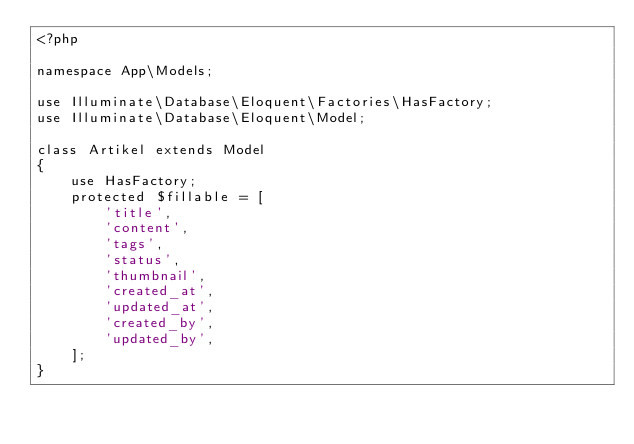Convert code to text. <code><loc_0><loc_0><loc_500><loc_500><_PHP_><?php

namespace App\Models;

use Illuminate\Database\Eloquent\Factories\HasFactory;
use Illuminate\Database\Eloquent\Model;

class Artikel extends Model
{
    use HasFactory;
    protected $fillable = [
        'title',
        'content',
        'tags',
        'status',
        'thumbnail',
        'created_at',
        'updated_at',
        'created_by',
        'updated_by',
    ];
}
</code> 